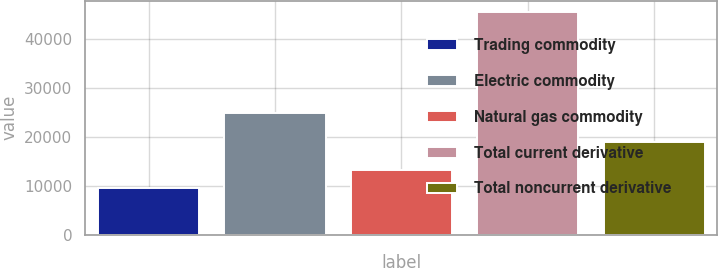Convert chart. <chart><loc_0><loc_0><loc_500><loc_500><bar_chart><fcel>Trading commodity<fcel>Electric commodity<fcel>Natural gas commodity<fcel>Total current derivative<fcel>Total noncurrent derivative<nl><fcel>9607<fcel>24965<fcel>13212<fcel>45657<fcel>19118<nl></chart> 